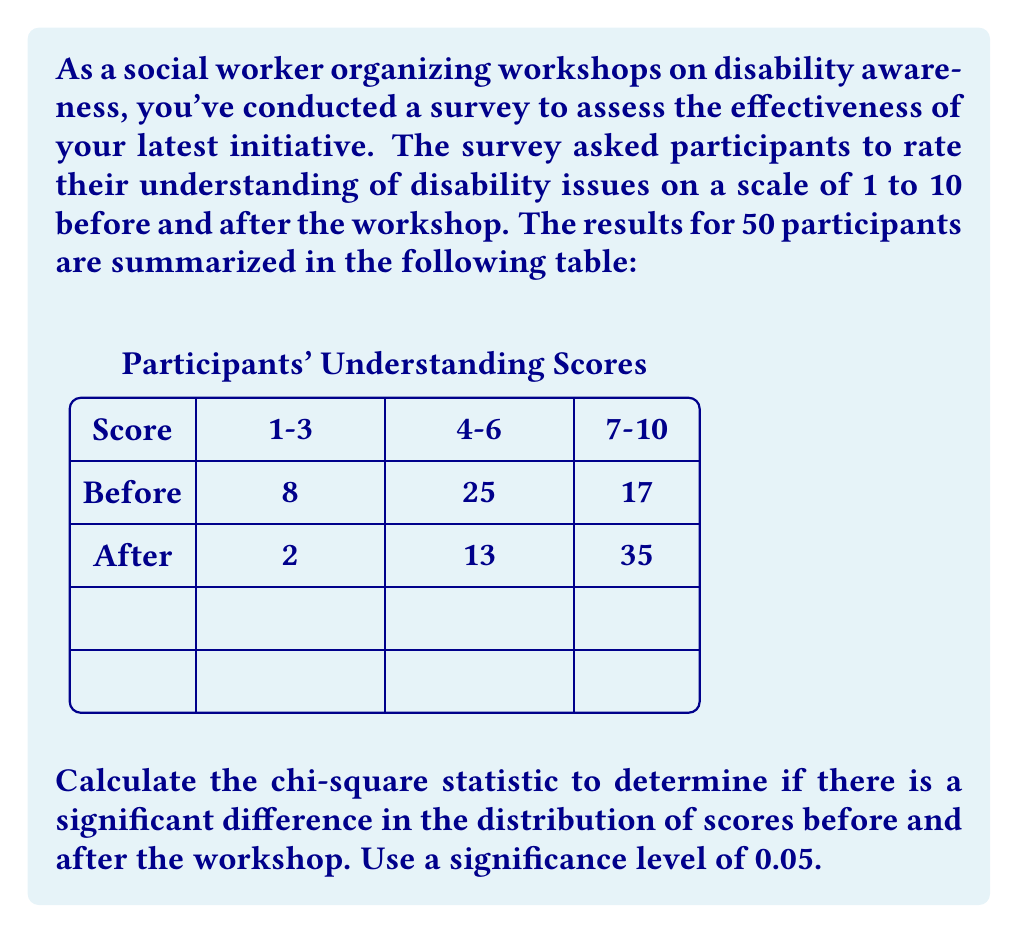Teach me how to tackle this problem. To calculate the chi-square statistic and determine if there's a significant difference in the distribution of scores, we'll follow these steps:

1) First, let's set up our observed frequencies:

   | Score | Before | After |
   |-------|--------|-------|
   | 1-3   |   8    |   2   |
   | 4-6   |   25   |   13  |
   | 7-10  |   17   |   35  |

2) Calculate the row and column totals:

   | Score | Before | After | Total |
   |-------|--------|-------|-------|
   | 1-3   |   8    |   2   |  10   |
   | 4-6   |   25   |   13  |  38   |
   | 7-10  |   17   |   35  |  52   |
   | Total |   50   |   50  |  100  |

3) Calculate the expected frequencies for each cell:
   Expected = (Row Total × Column Total) ÷ Grand Total

   For example, for "Before, 1-3":
   $E = (10 × 50) ÷ 100 = 5$

   Complete table of expected frequencies:

   | Score | Before | After |
   |-------|--------|-------|
   | 1-3   |   5    |   5   |
   | 4-6   |   19   |   19  |
   | 7-10  |   26   |   26  |

4) Calculate the chi-square statistic:
   $\chi^2 = \sum \frac{(O - E)^2}{E}$

   Where O is the observed frequency and E is the expected frequency.

   $\chi^2 = \frac{(8-5)^2}{5} + \frac{(2-5)^2}{5} + \frac{(25-19)^2}{19} + \frac{(13-19)^2}{19} + \frac{(17-26)^2}{26} + \frac{(35-26)^2}{26}$

   $\chi^2 = 1.8 + 1.8 + 1.89 + 1.89 + 3.12 + 3.12 = 13.62$

5) Determine the degrees of freedom:
   df = (rows - 1) × (columns - 1) = (3 - 1) × (2 - 1) = 2

6) Compare the calculated $\chi^2$ value to the critical value:
   For df = 2 and α = 0.05, the critical value is 5.991.

   Since 13.62 > 5.991, we reject the null hypothesis.

Therefore, there is a significant difference in the distribution of scores before and after the workshop at the 0.05 significance level.
Answer: $\chi^2 = 13.62$, significant difference (p < 0.05) 